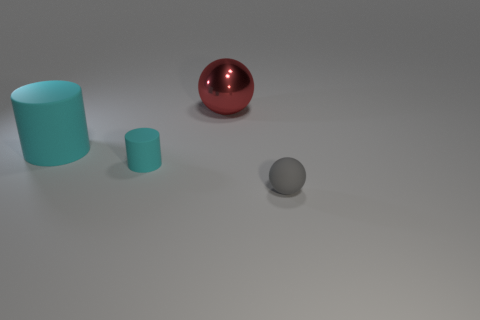Can you tell me the order of the objects from left to right? From left to right, there appears to be a matte cyan cylinder, a glossy red sphere, and a small grey matte rubber ball. 